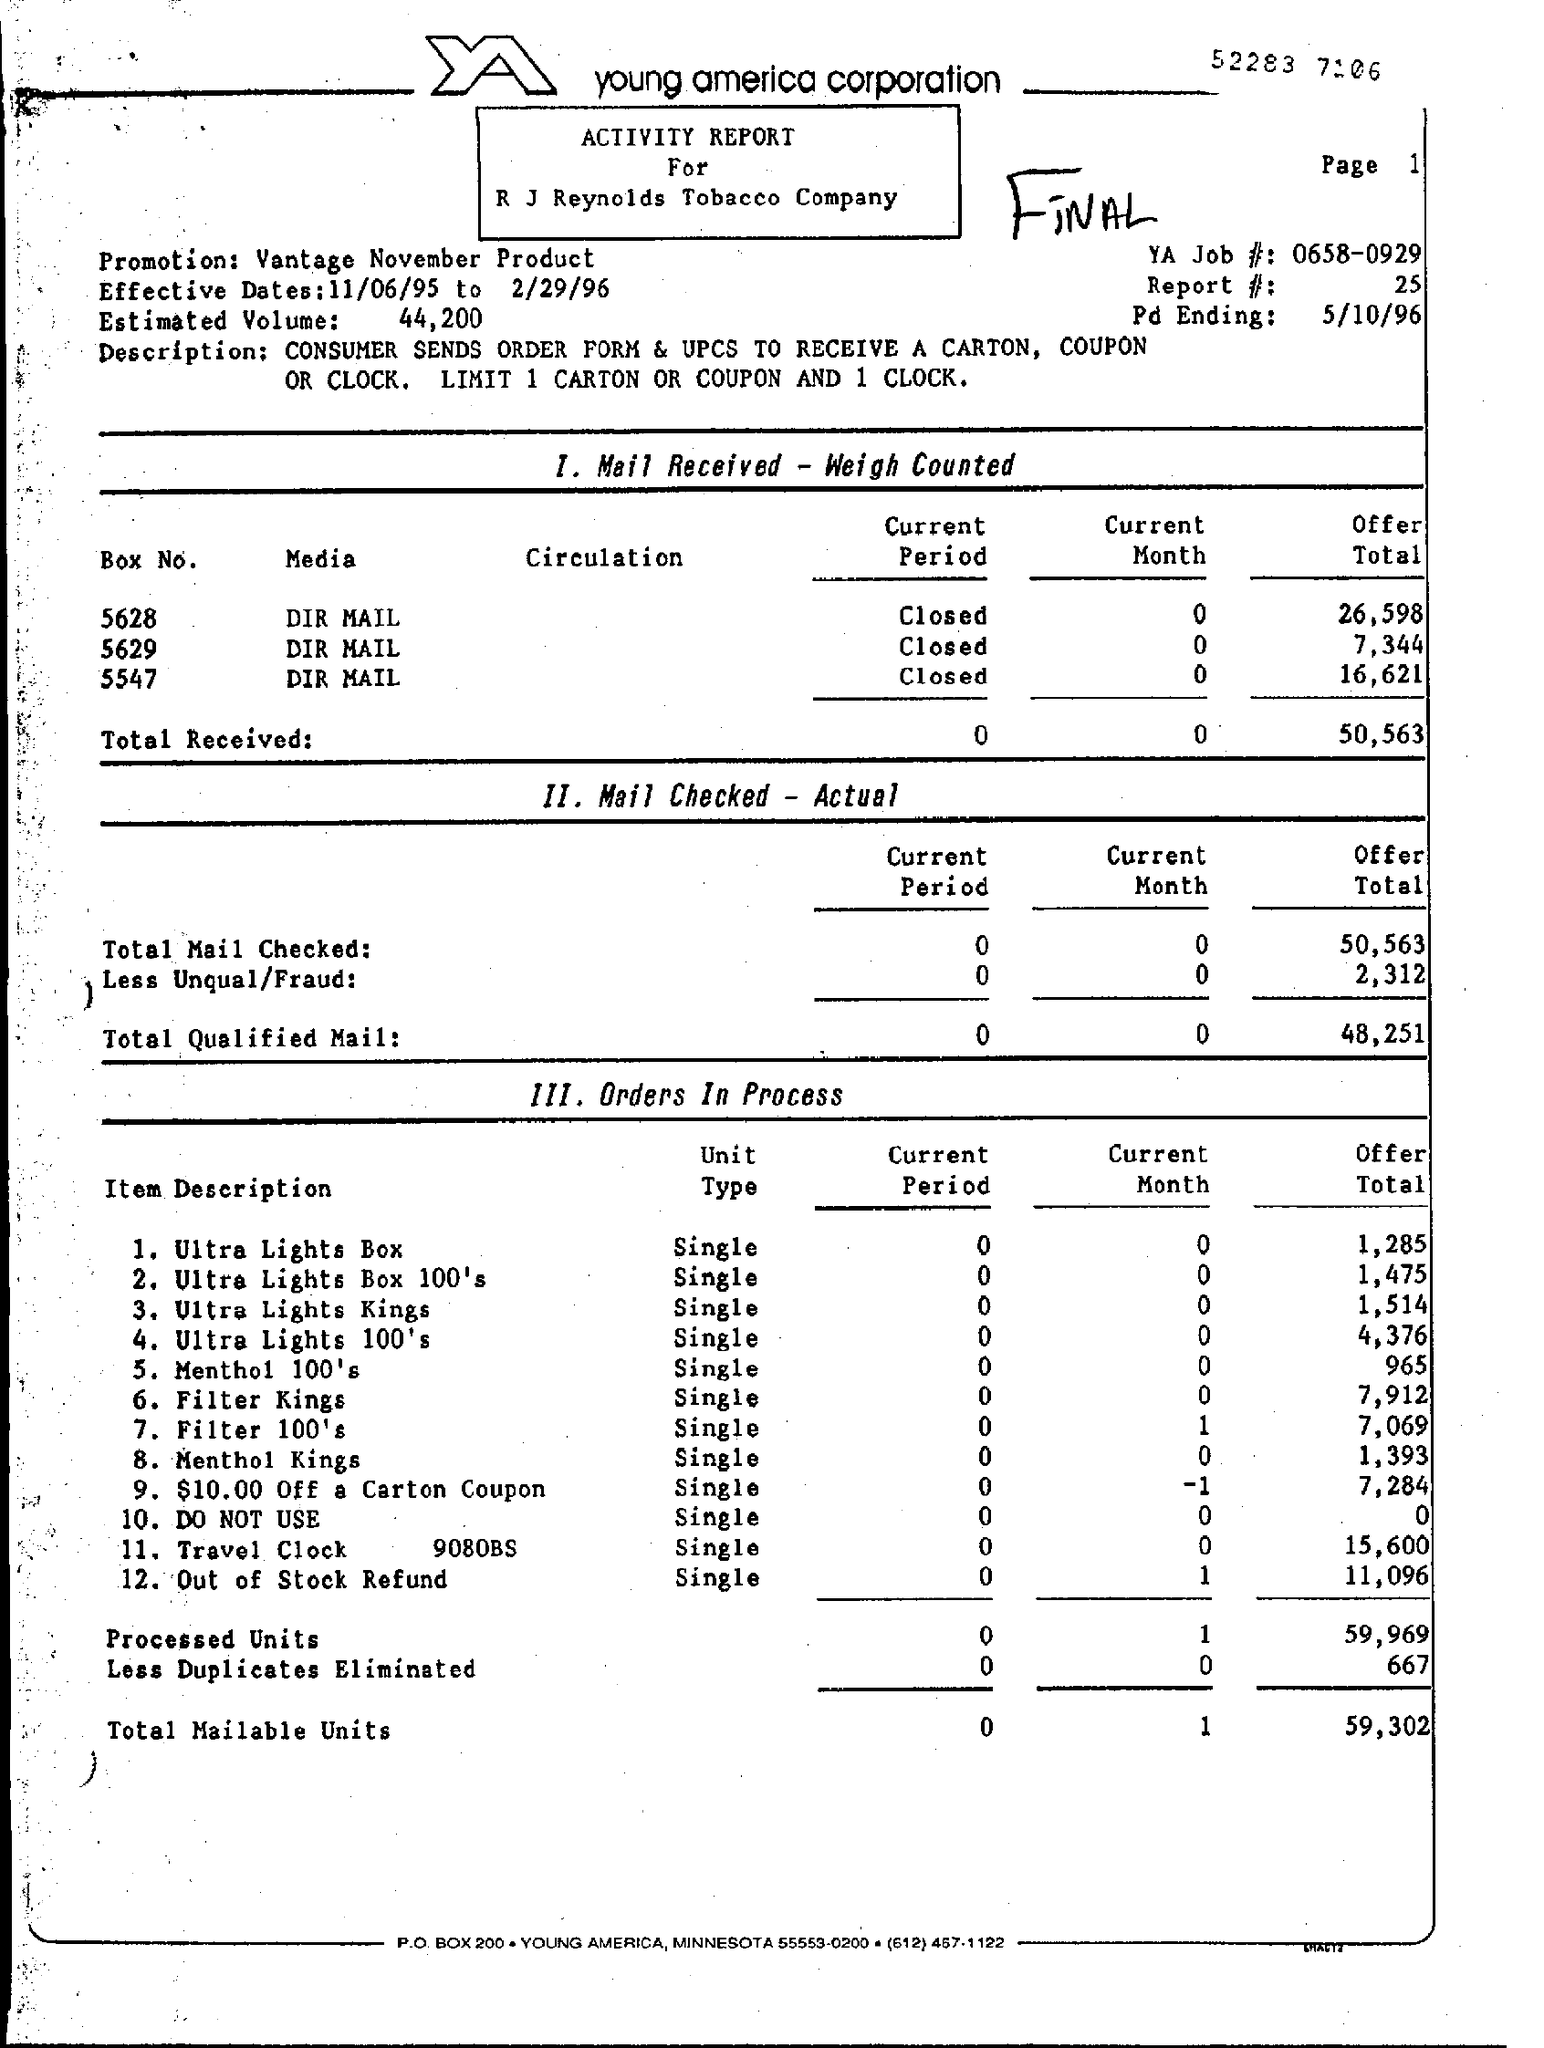What is the 'Estimated Volume' ?
Offer a very short reply. 44,200. 